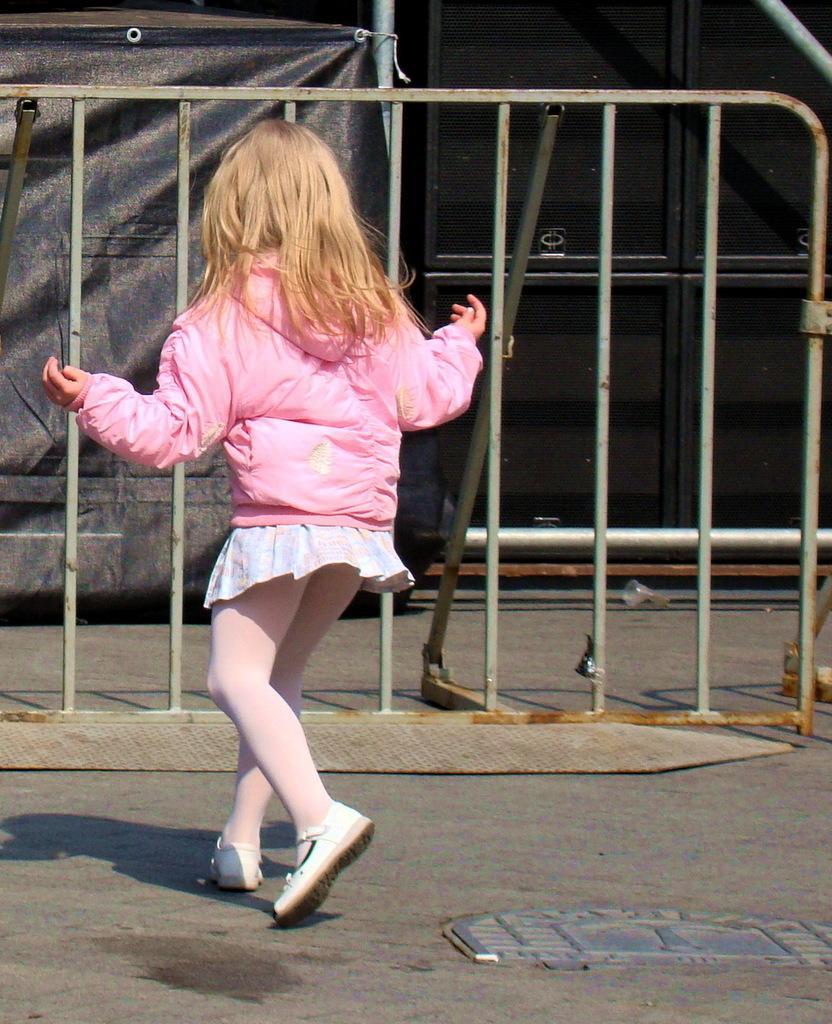Please provide a concise description of this image. On the left side, there is a girl in pink color jacket, running on the road. Beside her, there is a manhole. In the background, there is a fence, there is a black color sheet and there are boxes. 